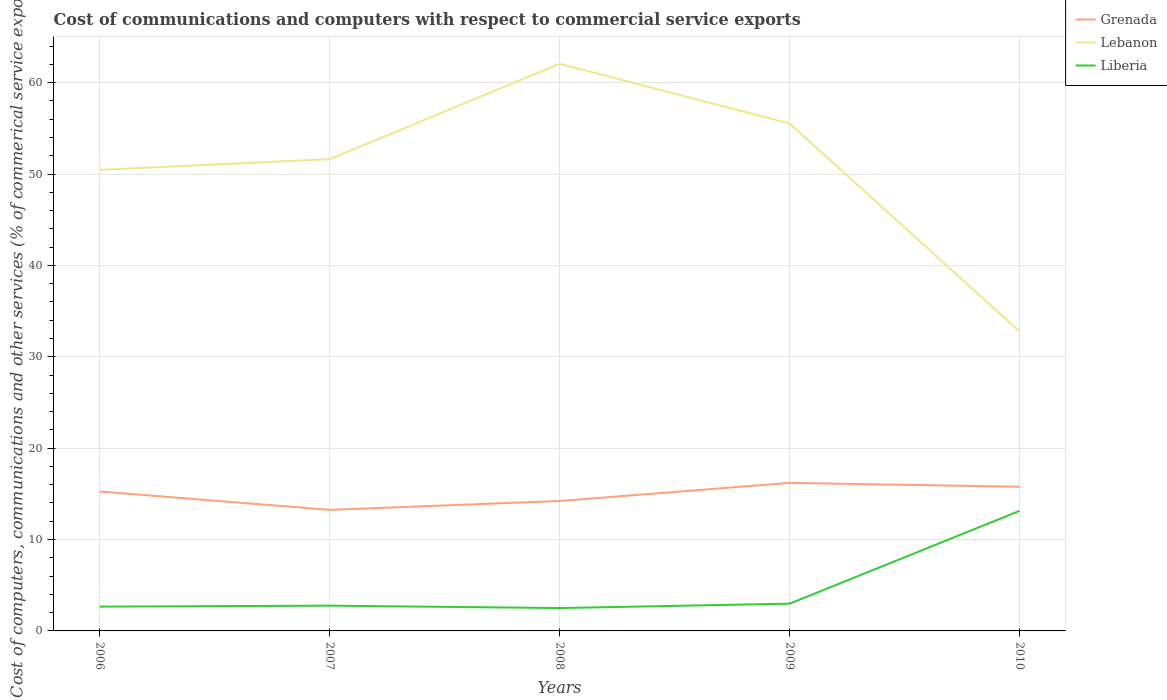Does the line corresponding to Liberia intersect with the line corresponding to Lebanon?
Provide a succinct answer. No. Across all years, what is the maximum cost of communications and computers in Lebanon?
Your answer should be compact. 32.77. What is the total cost of communications and computers in Liberia in the graph?
Ensure brevity in your answer.  -10.37. What is the difference between the highest and the second highest cost of communications and computers in Lebanon?
Offer a terse response. 29.29. What is the difference between the highest and the lowest cost of communications and computers in Grenada?
Ensure brevity in your answer.  3. What is the difference between two consecutive major ticks on the Y-axis?
Your answer should be very brief. 10. Are the values on the major ticks of Y-axis written in scientific E-notation?
Offer a very short reply. No. Does the graph contain grids?
Offer a very short reply. Yes. How many legend labels are there?
Give a very brief answer. 3. What is the title of the graph?
Make the answer very short. Cost of communications and computers with respect to commercial service exports. What is the label or title of the X-axis?
Provide a short and direct response. Years. What is the label or title of the Y-axis?
Offer a very short reply. Cost of computers, communications and other services (% of commerical service exports). What is the Cost of computers, communications and other services (% of commerical service exports) in Grenada in 2006?
Offer a terse response. 15.26. What is the Cost of computers, communications and other services (% of commerical service exports) of Lebanon in 2006?
Your answer should be compact. 50.46. What is the Cost of computers, communications and other services (% of commerical service exports) in Liberia in 2006?
Keep it short and to the point. 2.66. What is the Cost of computers, communications and other services (% of commerical service exports) of Grenada in 2007?
Make the answer very short. 13.25. What is the Cost of computers, communications and other services (% of commerical service exports) of Lebanon in 2007?
Provide a short and direct response. 51.63. What is the Cost of computers, communications and other services (% of commerical service exports) in Liberia in 2007?
Your answer should be very brief. 2.76. What is the Cost of computers, communications and other services (% of commerical service exports) of Grenada in 2008?
Keep it short and to the point. 14.22. What is the Cost of computers, communications and other services (% of commerical service exports) in Lebanon in 2008?
Offer a terse response. 62.07. What is the Cost of computers, communications and other services (% of commerical service exports) in Liberia in 2008?
Provide a short and direct response. 2.5. What is the Cost of computers, communications and other services (% of commerical service exports) of Grenada in 2009?
Give a very brief answer. 16.2. What is the Cost of computers, communications and other services (% of commerical service exports) in Lebanon in 2009?
Your answer should be very brief. 55.53. What is the Cost of computers, communications and other services (% of commerical service exports) in Liberia in 2009?
Give a very brief answer. 2.98. What is the Cost of computers, communications and other services (% of commerical service exports) in Grenada in 2010?
Offer a very short reply. 15.78. What is the Cost of computers, communications and other services (% of commerical service exports) of Lebanon in 2010?
Ensure brevity in your answer.  32.77. What is the Cost of computers, communications and other services (% of commerical service exports) in Liberia in 2010?
Your answer should be very brief. 13.14. Across all years, what is the maximum Cost of computers, communications and other services (% of commerical service exports) in Grenada?
Provide a succinct answer. 16.2. Across all years, what is the maximum Cost of computers, communications and other services (% of commerical service exports) in Lebanon?
Keep it short and to the point. 62.07. Across all years, what is the maximum Cost of computers, communications and other services (% of commerical service exports) in Liberia?
Your answer should be compact. 13.14. Across all years, what is the minimum Cost of computers, communications and other services (% of commerical service exports) in Grenada?
Provide a short and direct response. 13.25. Across all years, what is the minimum Cost of computers, communications and other services (% of commerical service exports) in Lebanon?
Give a very brief answer. 32.77. Across all years, what is the minimum Cost of computers, communications and other services (% of commerical service exports) in Liberia?
Ensure brevity in your answer.  2.5. What is the total Cost of computers, communications and other services (% of commerical service exports) in Grenada in the graph?
Offer a very short reply. 74.71. What is the total Cost of computers, communications and other services (% of commerical service exports) in Lebanon in the graph?
Your answer should be compact. 252.46. What is the total Cost of computers, communications and other services (% of commerical service exports) in Liberia in the graph?
Your answer should be compact. 24.05. What is the difference between the Cost of computers, communications and other services (% of commerical service exports) of Grenada in 2006 and that in 2007?
Provide a short and direct response. 2.01. What is the difference between the Cost of computers, communications and other services (% of commerical service exports) in Lebanon in 2006 and that in 2007?
Ensure brevity in your answer.  -1.17. What is the difference between the Cost of computers, communications and other services (% of commerical service exports) in Liberia in 2006 and that in 2007?
Ensure brevity in your answer.  -0.11. What is the difference between the Cost of computers, communications and other services (% of commerical service exports) in Grenada in 2006 and that in 2008?
Keep it short and to the point. 1.04. What is the difference between the Cost of computers, communications and other services (% of commerical service exports) of Lebanon in 2006 and that in 2008?
Keep it short and to the point. -11.61. What is the difference between the Cost of computers, communications and other services (% of commerical service exports) in Liberia in 2006 and that in 2008?
Your response must be concise. 0.16. What is the difference between the Cost of computers, communications and other services (% of commerical service exports) in Grenada in 2006 and that in 2009?
Keep it short and to the point. -0.95. What is the difference between the Cost of computers, communications and other services (% of commerical service exports) in Lebanon in 2006 and that in 2009?
Offer a very short reply. -5.07. What is the difference between the Cost of computers, communications and other services (% of commerical service exports) of Liberia in 2006 and that in 2009?
Offer a very short reply. -0.32. What is the difference between the Cost of computers, communications and other services (% of commerical service exports) in Grenada in 2006 and that in 2010?
Ensure brevity in your answer.  -0.52. What is the difference between the Cost of computers, communications and other services (% of commerical service exports) of Lebanon in 2006 and that in 2010?
Provide a short and direct response. 17.68. What is the difference between the Cost of computers, communications and other services (% of commerical service exports) in Liberia in 2006 and that in 2010?
Provide a short and direct response. -10.48. What is the difference between the Cost of computers, communications and other services (% of commerical service exports) in Grenada in 2007 and that in 2008?
Keep it short and to the point. -0.97. What is the difference between the Cost of computers, communications and other services (% of commerical service exports) in Lebanon in 2007 and that in 2008?
Your answer should be very brief. -10.44. What is the difference between the Cost of computers, communications and other services (% of commerical service exports) in Liberia in 2007 and that in 2008?
Keep it short and to the point. 0.26. What is the difference between the Cost of computers, communications and other services (% of commerical service exports) of Grenada in 2007 and that in 2009?
Give a very brief answer. -2.95. What is the difference between the Cost of computers, communications and other services (% of commerical service exports) of Lebanon in 2007 and that in 2009?
Your answer should be compact. -3.9. What is the difference between the Cost of computers, communications and other services (% of commerical service exports) of Liberia in 2007 and that in 2009?
Provide a succinct answer. -0.22. What is the difference between the Cost of computers, communications and other services (% of commerical service exports) of Grenada in 2007 and that in 2010?
Provide a succinct answer. -2.53. What is the difference between the Cost of computers, communications and other services (% of commerical service exports) of Lebanon in 2007 and that in 2010?
Ensure brevity in your answer.  18.86. What is the difference between the Cost of computers, communications and other services (% of commerical service exports) in Liberia in 2007 and that in 2010?
Your answer should be compact. -10.37. What is the difference between the Cost of computers, communications and other services (% of commerical service exports) in Grenada in 2008 and that in 2009?
Make the answer very short. -1.99. What is the difference between the Cost of computers, communications and other services (% of commerical service exports) of Lebanon in 2008 and that in 2009?
Give a very brief answer. 6.54. What is the difference between the Cost of computers, communications and other services (% of commerical service exports) of Liberia in 2008 and that in 2009?
Your answer should be compact. -0.48. What is the difference between the Cost of computers, communications and other services (% of commerical service exports) of Grenada in 2008 and that in 2010?
Keep it short and to the point. -1.56. What is the difference between the Cost of computers, communications and other services (% of commerical service exports) in Lebanon in 2008 and that in 2010?
Keep it short and to the point. 29.29. What is the difference between the Cost of computers, communications and other services (% of commerical service exports) in Liberia in 2008 and that in 2010?
Make the answer very short. -10.64. What is the difference between the Cost of computers, communications and other services (% of commerical service exports) in Grenada in 2009 and that in 2010?
Your answer should be compact. 0.42. What is the difference between the Cost of computers, communications and other services (% of commerical service exports) in Lebanon in 2009 and that in 2010?
Your answer should be very brief. 22.76. What is the difference between the Cost of computers, communications and other services (% of commerical service exports) of Liberia in 2009 and that in 2010?
Offer a terse response. -10.15. What is the difference between the Cost of computers, communications and other services (% of commerical service exports) in Grenada in 2006 and the Cost of computers, communications and other services (% of commerical service exports) in Lebanon in 2007?
Your answer should be compact. -36.37. What is the difference between the Cost of computers, communications and other services (% of commerical service exports) in Grenada in 2006 and the Cost of computers, communications and other services (% of commerical service exports) in Liberia in 2007?
Your response must be concise. 12.49. What is the difference between the Cost of computers, communications and other services (% of commerical service exports) of Lebanon in 2006 and the Cost of computers, communications and other services (% of commerical service exports) of Liberia in 2007?
Offer a very short reply. 47.69. What is the difference between the Cost of computers, communications and other services (% of commerical service exports) of Grenada in 2006 and the Cost of computers, communications and other services (% of commerical service exports) of Lebanon in 2008?
Give a very brief answer. -46.81. What is the difference between the Cost of computers, communications and other services (% of commerical service exports) in Grenada in 2006 and the Cost of computers, communications and other services (% of commerical service exports) in Liberia in 2008?
Ensure brevity in your answer.  12.76. What is the difference between the Cost of computers, communications and other services (% of commerical service exports) in Lebanon in 2006 and the Cost of computers, communications and other services (% of commerical service exports) in Liberia in 2008?
Your response must be concise. 47.96. What is the difference between the Cost of computers, communications and other services (% of commerical service exports) in Grenada in 2006 and the Cost of computers, communications and other services (% of commerical service exports) in Lebanon in 2009?
Your answer should be very brief. -40.27. What is the difference between the Cost of computers, communications and other services (% of commerical service exports) of Grenada in 2006 and the Cost of computers, communications and other services (% of commerical service exports) of Liberia in 2009?
Provide a short and direct response. 12.27. What is the difference between the Cost of computers, communications and other services (% of commerical service exports) of Lebanon in 2006 and the Cost of computers, communications and other services (% of commerical service exports) of Liberia in 2009?
Give a very brief answer. 47.47. What is the difference between the Cost of computers, communications and other services (% of commerical service exports) of Grenada in 2006 and the Cost of computers, communications and other services (% of commerical service exports) of Lebanon in 2010?
Your answer should be very brief. -17.51. What is the difference between the Cost of computers, communications and other services (% of commerical service exports) in Grenada in 2006 and the Cost of computers, communications and other services (% of commerical service exports) in Liberia in 2010?
Your answer should be very brief. 2.12. What is the difference between the Cost of computers, communications and other services (% of commerical service exports) of Lebanon in 2006 and the Cost of computers, communications and other services (% of commerical service exports) of Liberia in 2010?
Keep it short and to the point. 37.32. What is the difference between the Cost of computers, communications and other services (% of commerical service exports) of Grenada in 2007 and the Cost of computers, communications and other services (% of commerical service exports) of Lebanon in 2008?
Your answer should be very brief. -48.82. What is the difference between the Cost of computers, communications and other services (% of commerical service exports) in Grenada in 2007 and the Cost of computers, communications and other services (% of commerical service exports) in Liberia in 2008?
Keep it short and to the point. 10.75. What is the difference between the Cost of computers, communications and other services (% of commerical service exports) in Lebanon in 2007 and the Cost of computers, communications and other services (% of commerical service exports) in Liberia in 2008?
Keep it short and to the point. 49.13. What is the difference between the Cost of computers, communications and other services (% of commerical service exports) in Grenada in 2007 and the Cost of computers, communications and other services (% of commerical service exports) in Lebanon in 2009?
Your response must be concise. -42.28. What is the difference between the Cost of computers, communications and other services (% of commerical service exports) in Grenada in 2007 and the Cost of computers, communications and other services (% of commerical service exports) in Liberia in 2009?
Keep it short and to the point. 10.27. What is the difference between the Cost of computers, communications and other services (% of commerical service exports) of Lebanon in 2007 and the Cost of computers, communications and other services (% of commerical service exports) of Liberia in 2009?
Offer a terse response. 48.65. What is the difference between the Cost of computers, communications and other services (% of commerical service exports) in Grenada in 2007 and the Cost of computers, communications and other services (% of commerical service exports) in Lebanon in 2010?
Your answer should be very brief. -19.52. What is the difference between the Cost of computers, communications and other services (% of commerical service exports) in Grenada in 2007 and the Cost of computers, communications and other services (% of commerical service exports) in Liberia in 2010?
Offer a very short reply. 0.11. What is the difference between the Cost of computers, communications and other services (% of commerical service exports) in Lebanon in 2007 and the Cost of computers, communications and other services (% of commerical service exports) in Liberia in 2010?
Provide a short and direct response. 38.49. What is the difference between the Cost of computers, communications and other services (% of commerical service exports) in Grenada in 2008 and the Cost of computers, communications and other services (% of commerical service exports) in Lebanon in 2009?
Provide a short and direct response. -41.31. What is the difference between the Cost of computers, communications and other services (% of commerical service exports) of Grenada in 2008 and the Cost of computers, communications and other services (% of commerical service exports) of Liberia in 2009?
Offer a terse response. 11.23. What is the difference between the Cost of computers, communications and other services (% of commerical service exports) of Lebanon in 2008 and the Cost of computers, communications and other services (% of commerical service exports) of Liberia in 2009?
Make the answer very short. 59.08. What is the difference between the Cost of computers, communications and other services (% of commerical service exports) of Grenada in 2008 and the Cost of computers, communications and other services (% of commerical service exports) of Lebanon in 2010?
Offer a terse response. -18.55. What is the difference between the Cost of computers, communications and other services (% of commerical service exports) in Grenada in 2008 and the Cost of computers, communications and other services (% of commerical service exports) in Liberia in 2010?
Make the answer very short. 1.08. What is the difference between the Cost of computers, communications and other services (% of commerical service exports) in Lebanon in 2008 and the Cost of computers, communications and other services (% of commerical service exports) in Liberia in 2010?
Provide a succinct answer. 48.93. What is the difference between the Cost of computers, communications and other services (% of commerical service exports) in Grenada in 2009 and the Cost of computers, communications and other services (% of commerical service exports) in Lebanon in 2010?
Your answer should be very brief. -16.57. What is the difference between the Cost of computers, communications and other services (% of commerical service exports) in Grenada in 2009 and the Cost of computers, communications and other services (% of commerical service exports) in Liberia in 2010?
Make the answer very short. 3.07. What is the difference between the Cost of computers, communications and other services (% of commerical service exports) of Lebanon in 2009 and the Cost of computers, communications and other services (% of commerical service exports) of Liberia in 2010?
Offer a very short reply. 42.39. What is the average Cost of computers, communications and other services (% of commerical service exports) of Grenada per year?
Offer a very short reply. 14.94. What is the average Cost of computers, communications and other services (% of commerical service exports) in Lebanon per year?
Keep it short and to the point. 50.49. What is the average Cost of computers, communications and other services (% of commerical service exports) of Liberia per year?
Your answer should be compact. 4.81. In the year 2006, what is the difference between the Cost of computers, communications and other services (% of commerical service exports) in Grenada and Cost of computers, communications and other services (% of commerical service exports) in Lebanon?
Your answer should be very brief. -35.2. In the year 2006, what is the difference between the Cost of computers, communications and other services (% of commerical service exports) in Grenada and Cost of computers, communications and other services (% of commerical service exports) in Liberia?
Give a very brief answer. 12.6. In the year 2006, what is the difference between the Cost of computers, communications and other services (% of commerical service exports) in Lebanon and Cost of computers, communications and other services (% of commerical service exports) in Liberia?
Keep it short and to the point. 47.8. In the year 2007, what is the difference between the Cost of computers, communications and other services (% of commerical service exports) of Grenada and Cost of computers, communications and other services (% of commerical service exports) of Lebanon?
Make the answer very short. -38.38. In the year 2007, what is the difference between the Cost of computers, communications and other services (% of commerical service exports) of Grenada and Cost of computers, communications and other services (% of commerical service exports) of Liberia?
Keep it short and to the point. 10.49. In the year 2007, what is the difference between the Cost of computers, communications and other services (% of commerical service exports) in Lebanon and Cost of computers, communications and other services (% of commerical service exports) in Liberia?
Your answer should be compact. 48.86. In the year 2008, what is the difference between the Cost of computers, communications and other services (% of commerical service exports) in Grenada and Cost of computers, communications and other services (% of commerical service exports) in Lebanon?
Offer a terse response. -47.85. In the year 2008, what is the difference between the Cost of computers, communications and other services (% of commerical service exports) in Grenada and Cost of computers, communications and other services (% of commerical service exports) in Liberia?
Your response must be concise. 11.72. In the year 2008, what is the difference between the Cost of computers, communications and other services (% of commerical service exports) in Lebanon and Cost of computers, communications and other services (% of commerical service exports) in Liberia?
Ensure brevity in your answer.  59.57. In the year 2009, what is the difference between the Cost of computers, communications and other services (% of commerical service exports) of Grenada and Cost of computers, communications and other services (% of commerical service exports) of Lebanon?
Make the answer very short. -39.32. In the year 2009, what is the difference between the Cost of computers, communications and other services (% of commerical service exports) of Grenada and Cost of computers, communications and other services (% of commerical service exports) of Liberia?
Provide a succinct answer. 13.22. In the year 2009, what is the difference between the Cost of computers, communications and other services (% of commerical service exports) in Lebanon and Cost of computers, communications and other services (% of commerical service exports) in Liberia?
Provide a short and direct response. 52.55. In the year 2010, what is the difference between the Cost of computers, communications and other services (% of commerical service exports) of Grenada and Cost of computers, communications and other services (% of commerical service exports) of Lebanon?
Offer a terse response. -16.99. In the year 2010, what is the difference between the Cost of computers, communications and other services (% of commerical service exports) in Grenada and Cost of computers, communications and other services (% of commerical service exports) in Liberia?
Provide a short and direct response. 2.64. In the year 2010, what is the difference between the Cost of computers, communications and other services (% of commerical service exports) in Lebanon and Cost of computers, communications and other services (% of commerical service exports) in Liberia?
Provide a short and direct response. 19.63. What is the ratio of the Cost of computers, communications and other services (% of commerical service exports) of Grenada in 2006 to that in 2007?
Make the answer very short. 1.15. What is the ratio of the Cost of computers, communications and other services (% of commerical service exports) of Lebanon in 2006 to that in 2007?
Make the answer very short. 0.98. What is the ratio of the Cost of computers, communications and other services (% of commerical service exports) in Liberia in 2006 to that in 2007?
Make the answer very short. 0.96. What is the ratio of the Cost of computers, communications and other services (% of commerical service exports) of Grenada in 2006 to that in 2008?
Your response must be concise. 1.07. What is the ratio of the Cost of computers, communications and other services (% of commerical service exports) of Lebanon in 2006 to that in 2008?
Offer a terse response. 0.81. What is the ratio of the Cost of computers, communications and other services (% of commerical service exports) of Liberia in 2006 to that in 2008?
Offer a terse response. 1.06. What is the ratio of the Cost of computers, communications and other services (% of commerical service exports) of Grenada in 2006 to that in 2009?
Your answer should be compact. 0.94. What is the ratio of the Cost of computers, communications and other services (% of commerical service exports) in Lebanon in 2006 to that in 2009?
Give a very brief answer. 0.91. What is the ratio of the Cost of computers, communications and other services (% of commerical service exports) of Liberia in 2006 to that in 2009?
Give a very brief answer. 0.89. What is the ratio of the Cost of computers, communications and other services (% of commerical service exports) in Grenada in 2006 to that in 2010?
Ensure brevity in your answer.  0.97. What is the ratio of the Cost of computers, communications and other services (% of commerical service exports) in Lebanon in 2006 to that in 2010?
Provide a succinct answer. 1.54. What is the ratio of the Cost of computers, communications and other services (% of commerical service exports) of Liberia in 2006 to that in 2010?
Give a very brief answer. 0.2. What is the ratio of the Cost of computers, communications and other services (% of commerical service exports) in Grenada in 2007 to that in 2008?
Your answer should be very brief. 0.93. What is the ratio of the Cost of computers, communications and other services (% of commerical service exports) of Lebanon in 2007 to that in 2008?
Provide a short and direct response. 0.83. What is the ratio of the Cost of computers, communications and other services (% of commerical service exports) in Liberia in 2007 to that in 2008?
Keep it short and to the point. 1.11. What is the ratio of the Cost of computers, communications and other services (% of commerical service exports) in Grenada in 2007 to that in 2009?
Offer a terse response. 0.82. What is the ratio of the Cost of computers, communications and other services (% of commerical service exports) in Lebanon in 2007 to that in 2009?
Your answer should be compact. 0.93. What is the ratio of the Cost of computers, communications and other services (% of commerical service exports) of Liberia in 2007 to that in 2009?
Your response must be concise. 0.93. What is the ratio of the Cost of computers, communications and other services (% of commerical service exports) of Grenada in 2007 to that in 2010?
Your answer should be very brief. 0.84. What is the ratio of the Cost of computers, communications and other services (% of commerical service exports) in Lebanon in 2007 to that in 2010?
Your answer should be compact. 1.58. What is the ratio of the Cost of computers, communications and other services (% of commerical service exports) in Liberia in 2007 to that in 2010?
Ensure brevity in your answer.  0.21. What is the ratio of the Cost of computers, communications and other services (% of commerical service exports) of Grenada in 2008 to that in 2009?
Make the answer very short. 0.88. What is the ratio of the Cost of computers, communications and other services (% of commerical service exports) in Lebanon in 2008 to that in 2009?
Your answer should be very brief. 1.12. What is the ratio of the Cost of computers, communications and other services (% of commerical service exports) of Liberia in 2008 to that in 2009?
Make the answer very short. 0.84. What is the ratio of the Cost of computers, communications and other services (% of commerical service exports) of Grenada in 2008 to that in 2010?
Give a very brief answer. 0.9. What is the ratio of the Cost of computers, communications and other services (% of commerical service exports) of Lebanon in 2008 to that in 2010?
Provide a succinct answer. 1.89. What is the ratio of the Cost of computers, communications and other services (% of commerical service exports) of Liberia in 2008 to that in 2010?
Give a very brief answer. 0.19. What is the ratio of the Cost of computers, communications and other services (% of commerical service exports) in Grenada in 2009 to that in 2010?
Ensure brevity in your answer.  1.03. What is the ratio of the Cost of computers, communications and other services (% of commerical service exports) of Lebanon in 2009 to that in 2010?
Your answer should be compact. 1.69. What is the ratio of the Cost of computers, communications and other services (% of commerical service exports) in Liberia in 2009 to that in 2010?
Give a very brief answer. 0.23. What is the difference between the highest and the second highest Cost of computers, communications and other services (% of commerical service exports) of Grenada?
Your response must be concise. 0.42. What is the difference between the highest and the second highest Cost of computers, communications and other services (% of commerical service exports) of Lebanon?
Offer a very short reply. 6.54. What is the difference between the highest and the second highest Cost of computers, communications and other services (% of commerical service exports) in Liberia?
Offer a very short reply. 10.15. What is the difference between the highest and the lowest Cost of computers, communications and other services (% of commerical service exports) of Grenada?
Offer a very short reply. 2.95. What is the difference between the highest and the lowest Cost of computers, communications and other services (% of commerical service exports) of Lebanon?
Your response must be concise. 29.29. What is the difference between the highest and the lowest Cost of computers, communications and other services (% of commerical service exports) of Liberia?
Keep it short and to the point. 10.64. 